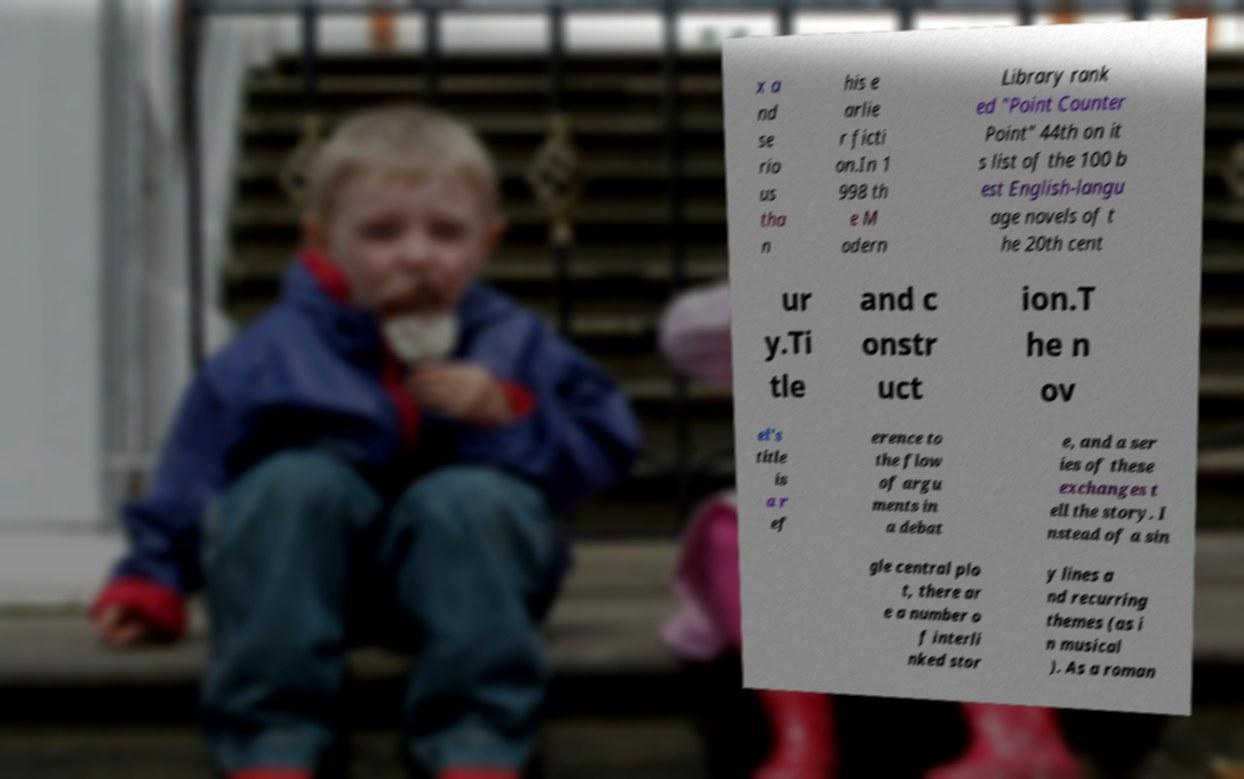I need the written content from this picture converted into text. Can you do that? x a nd se rio us tha n his e arlie r ficti on.In 1 998 th e M odern Library rank ed "Point Counter Point" 44th on it s list of the 100 b est English-langu age novels of t he 20th cent ur y.Ti tle and c onstr uct ion.T he n ov el's title is a r ef erence to the flow of argu ments in a debat e, and a ser ies of these exchanges t ell the story. I nstead of a sin gle central plo t, there ar e a number o f interli nked stor y lines a nd recurring themes (as i n musical ). As a roman 